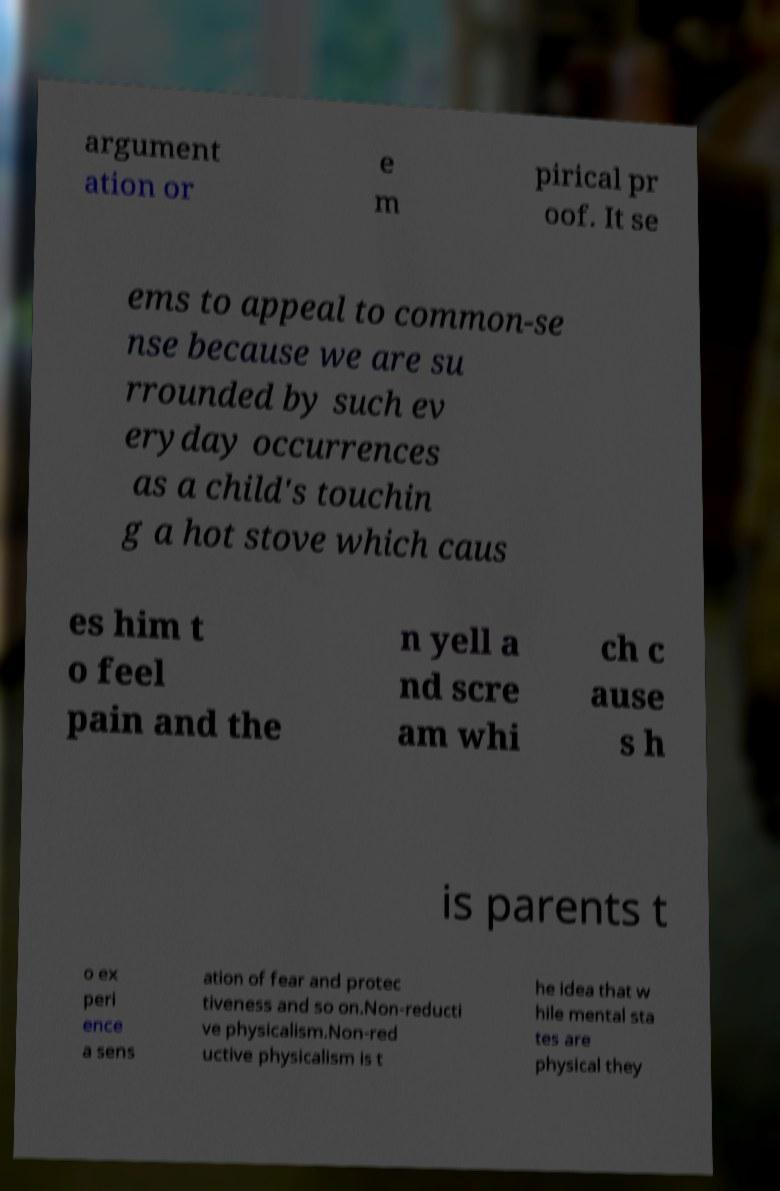Could you extract and type out the text from this image? argument ation or e m pirical pr oof. It se ems to appeal to common-se nse because we are su rrounded by such ev eryday occurrences as a child's touchin g a hot stove which caus es him t o feel pain and the n yell a nd scre am whi ch c ause s h is parents t o ex peri ence a sens ation of fear and protec tiveness and so on.Non-reducti ve physicalism.Non-red uctive physicalism is t he idea that w hile mental sta tes are physical they 